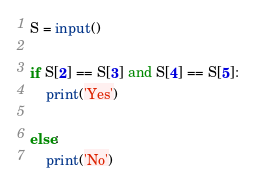Convert code to text. <code><loc_0><loc_0><loc_500><loc_500><_Python_>S = input()

if S[2] == S[3] and S[4] == S[5]:
    print('Yes')

else:
    print('No')</code> 